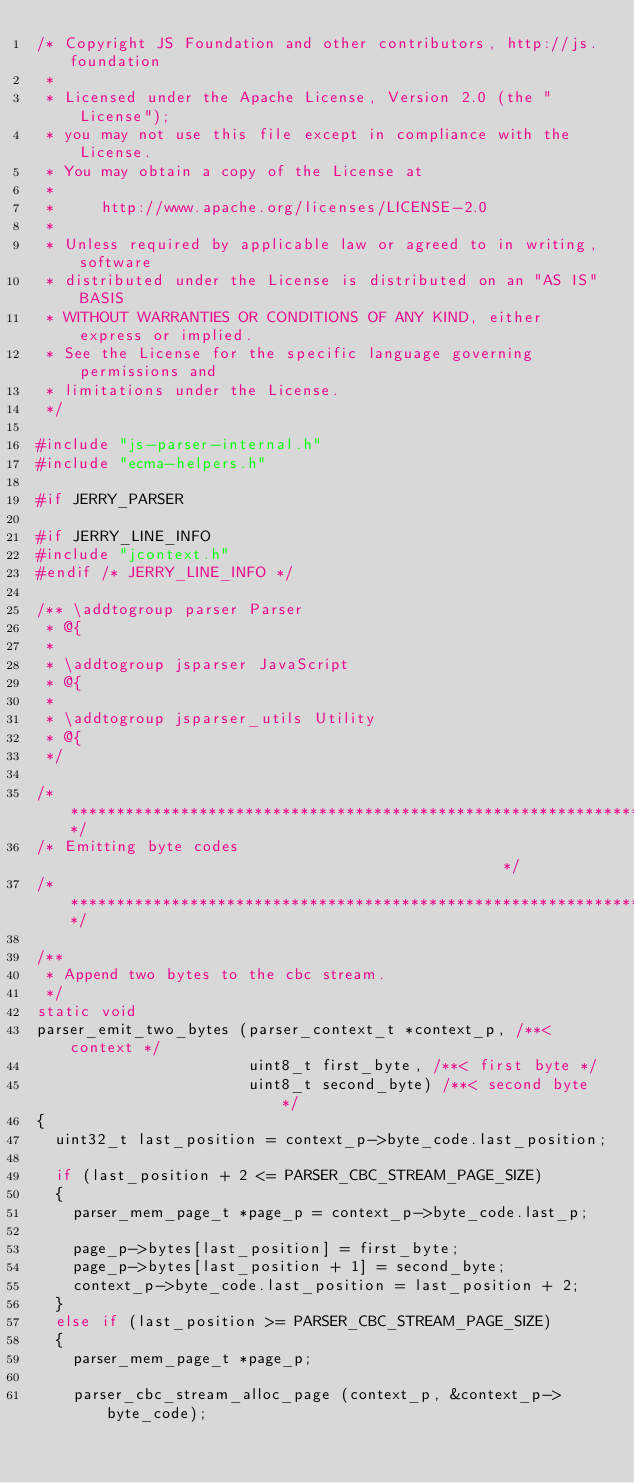<code> <loc_0><loc_0><loc_500><loc_500><_C_>/* Copyright JS Foundation and other contributors, http://js.foundation
 *
 * Licensed under the Apache License, Version 2.0 (the "License");
 * you may not use this file except in compliance with the License.
 * You may obtain a copy of the License at
 *
 *     http://www.apache.org/licenses/LICENSE-2.0
 *
 * Unless required by applicable law or agreed to in writing, software
 * distributed under the License is distributed on an "AS IS" BASIS
 * WITHOUT WARRANTIES OR CONDITIONS OF ANY KIND, either express or implied.
 * See the License for the specific language governing permissions and
 * limitations under the License.
 */

#include "js-parser-internal.h"
#include "ecma-helpers.h"

#if JERRY_PARSER

#if JERRY_LINE_INFO
#include "jcontext.h"
#endif /* JERRY_LINE_INFO */

/** \addtogroup parser Parser
 * @{
 *
 * \addtogroup jsparser JavaScript
 * @{
 *
 * \addtogroup jsparser_utils Utility
 * @{
 */

/**********************************************************************/
/* Emitting byte codes                                                */
/**********************************************************************/

/**
 * Append two bytes to the cbc stream.
 */
static void
parser_emit_two_bytes (parser_context_t *context_p, /**< context */
                       uint8_t first_byte, /**< first byte */
                       uint8_t second_byte) /**< second byte */
{
  uint32_t last_position = context_p->byte_code.last_position;

  if (last_position + 2 <= PARSER_CBC_STREAM_PAGE_SIZE)
  {
    parser_mem_page_t *page_p = context_p->byte_code.last_p;

    page_p->bytes[last_position] = first_byte;
    page_p->bytes[last_position + 1] = second_byte;
    context_p->byte_code.last_position = last_position + 2;
  }
  else if (last_position >= PARSER_CBC_STREAM_PAGE_SIZE)
  {
    parser_mem_page_t *page_p;

    parser_cbc_stream_alloc_page (context_p, &context_p->byte_code);</code> 